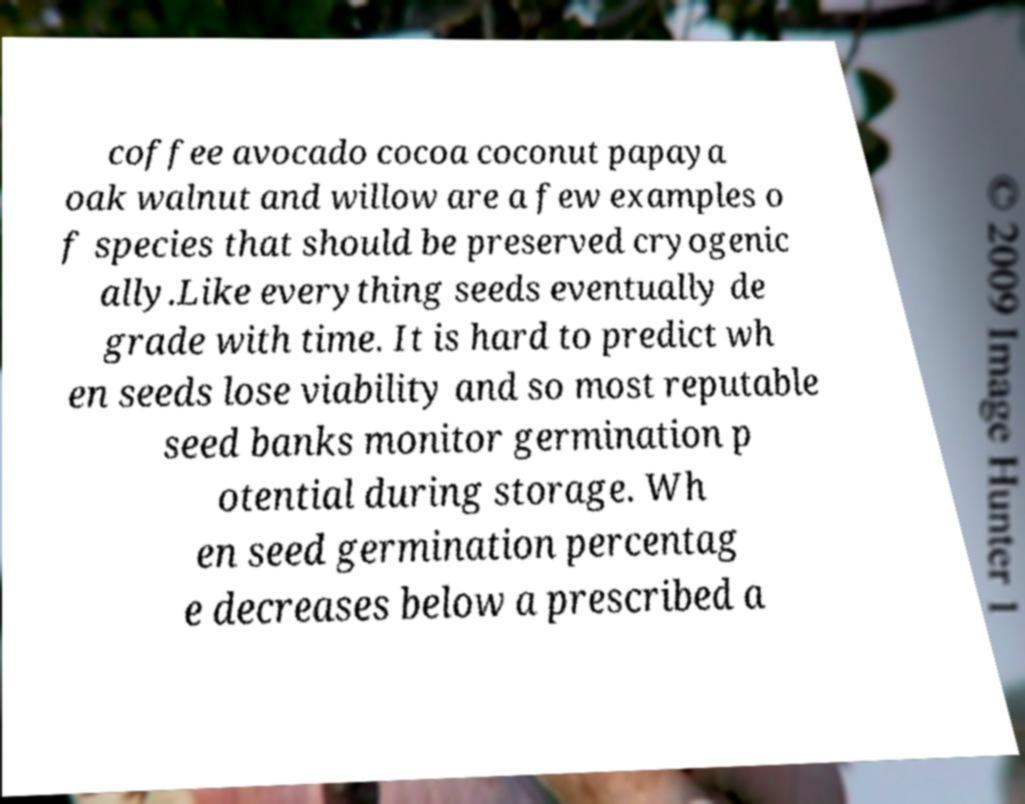Can you accurately transcribe the text from the provided image for me? coffee avocado cocoa coconut papaya oak walnut and willow are a few examples o f species that should be preserved cryogenic ally.Like everything seeds eventually de grade with time. It is hard to predict wh en seeds lose viability and so most reputable seed banks monitor germination p otential during storage. Wh en seed germination percentag e decreases below a prescribed a 